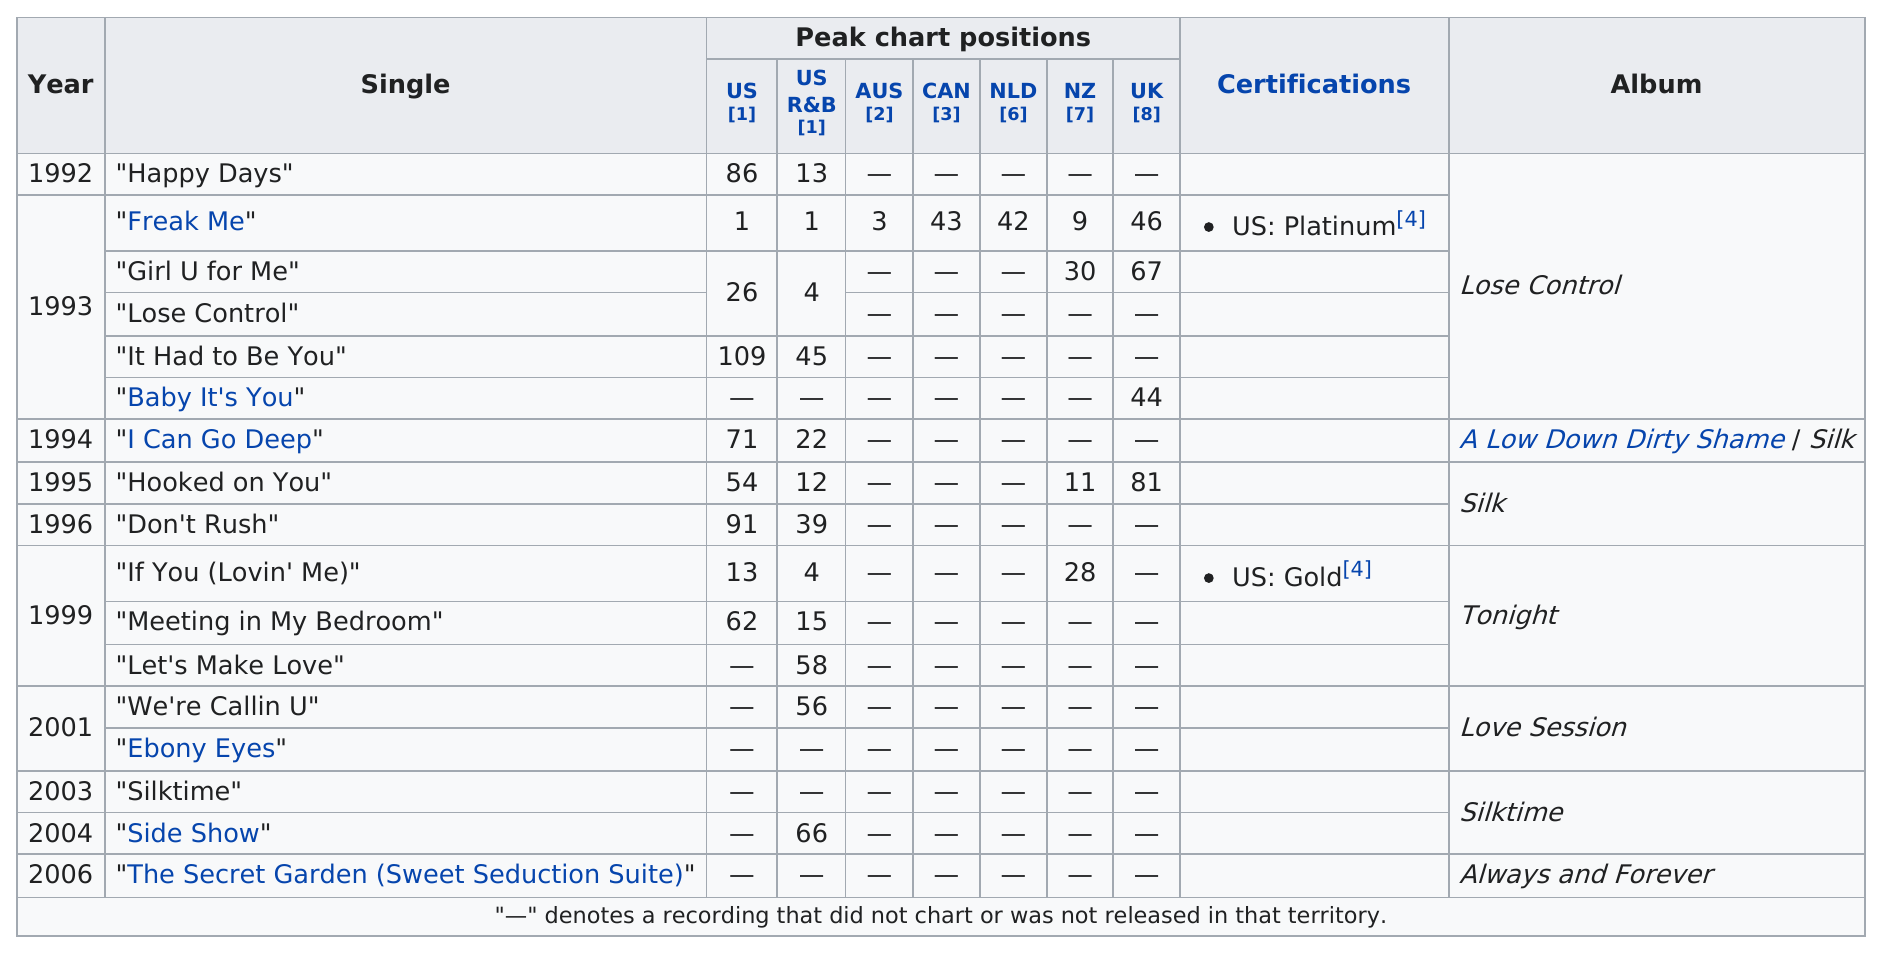Indicate a few pertinent items in this graphic. As of the US and US R&B charts, 'I Can Go Deep' was higher in ranking than 'Don't Rush'. Out of all the songs that charted the most times, 'Freak Me' is the one that stands out. 